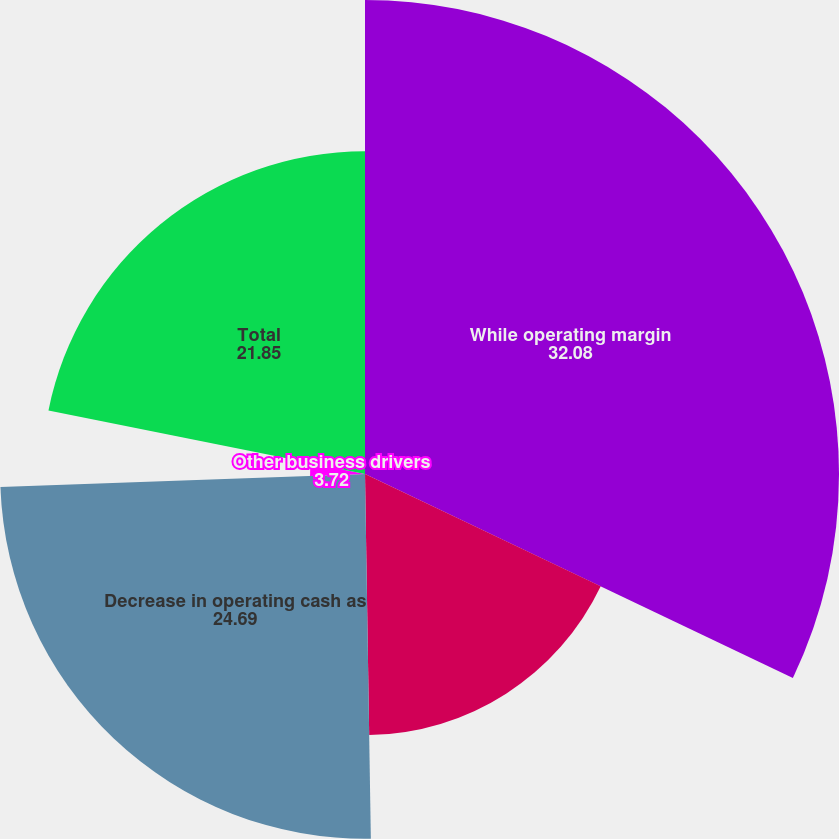Convert chart. <chart><loc_0><loc_0><loc_500><loc_500><pie_chart><fcel>While operating margin<fcel>Increase at IPP4 in Jordan<fcel>Decrease in operating cash as<fcel>Other business drivers<fcel>Total<nl><fcel>32.08%<fcel>17.67%<fcel>24.69%<fcel>3.72%<fcel>21.85%<nl></chart> 